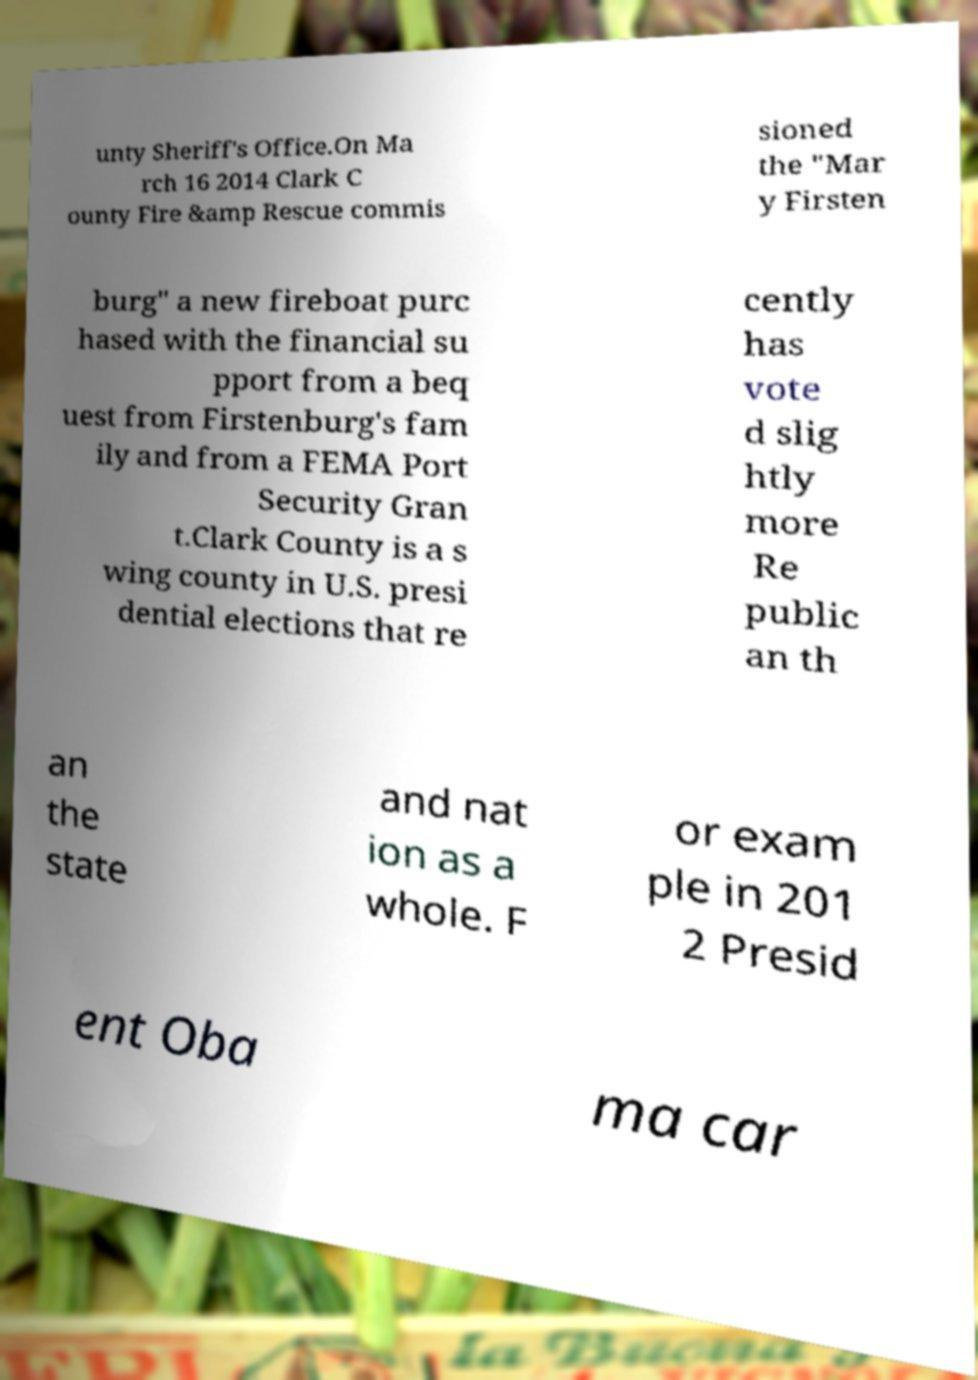Can you read and provide the text displayed in the image?This photo seems to have some interesting text. Can you extract and type it out for me? unty Sheriff's Office.On Ma rch 16 2014 Clark C ounty Fire &amp Rescue commis sioned the "Mar y Firsten burg" a new fireboat purc hased with the financial su pport from a beq uest from Firstenburg's fam ily and from a FEMA Port Security Gran t.Clark County is a s wing county in U.S. presi dential elections that re cently has vote d slig htly more Re public an th an the state and nat ion as a whole. F or exam ple in 201 2 Presid ent Oba ma car 